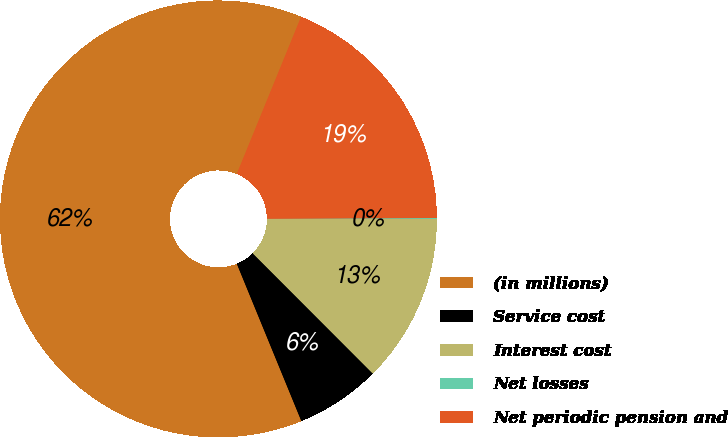Convert chart to OTSL. <chart><loc_0><loc_0><loc_500><loc_500><pie_chart><fcel>(in millions)<fcel>Service cost<fcel>Interest cost<fcel>Net losses<fcel>Net periodic pension and<nl><fcel>62.37%<fcel>6.29%<fcel>12.52%<fcel>0.06%<fcel>18.75%<nl></chart> 